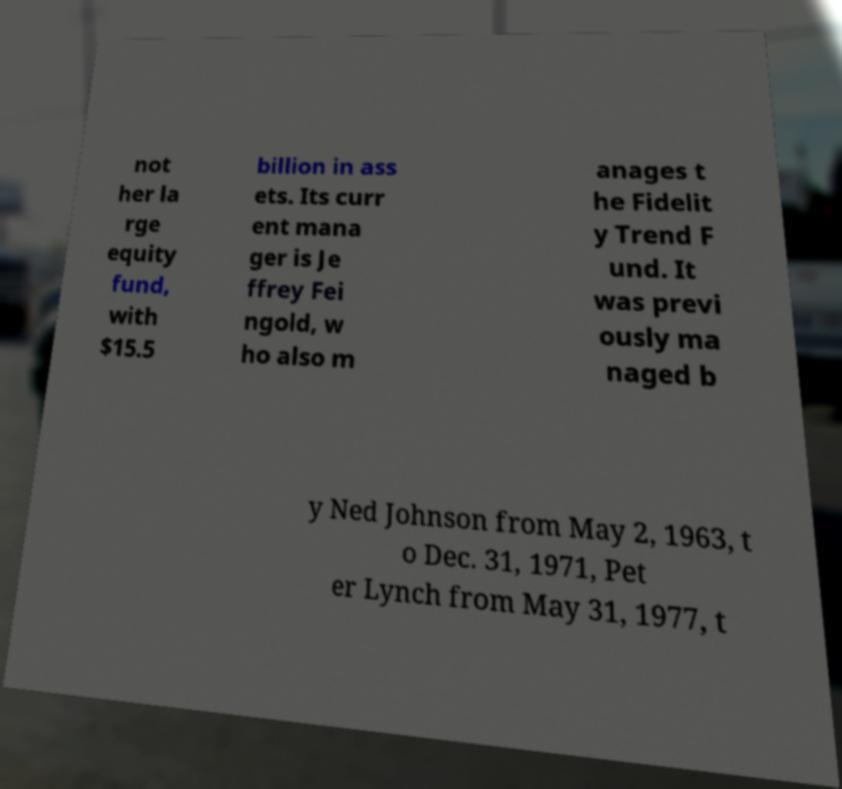I need the written content from this picture converted into text. Can you do that? not her la rge equity fund, with $15.5 billion in ass ets. Its curr ent mana ger is Je ffrey Fei ngold, w ho also m anages t he Fidelit y Trend F und. It was previ ously ma naged b y Ned Johnson from May 2, 1963, t o Dec. 31, 1971, Pet er Lynch from May 31, 1977, t 